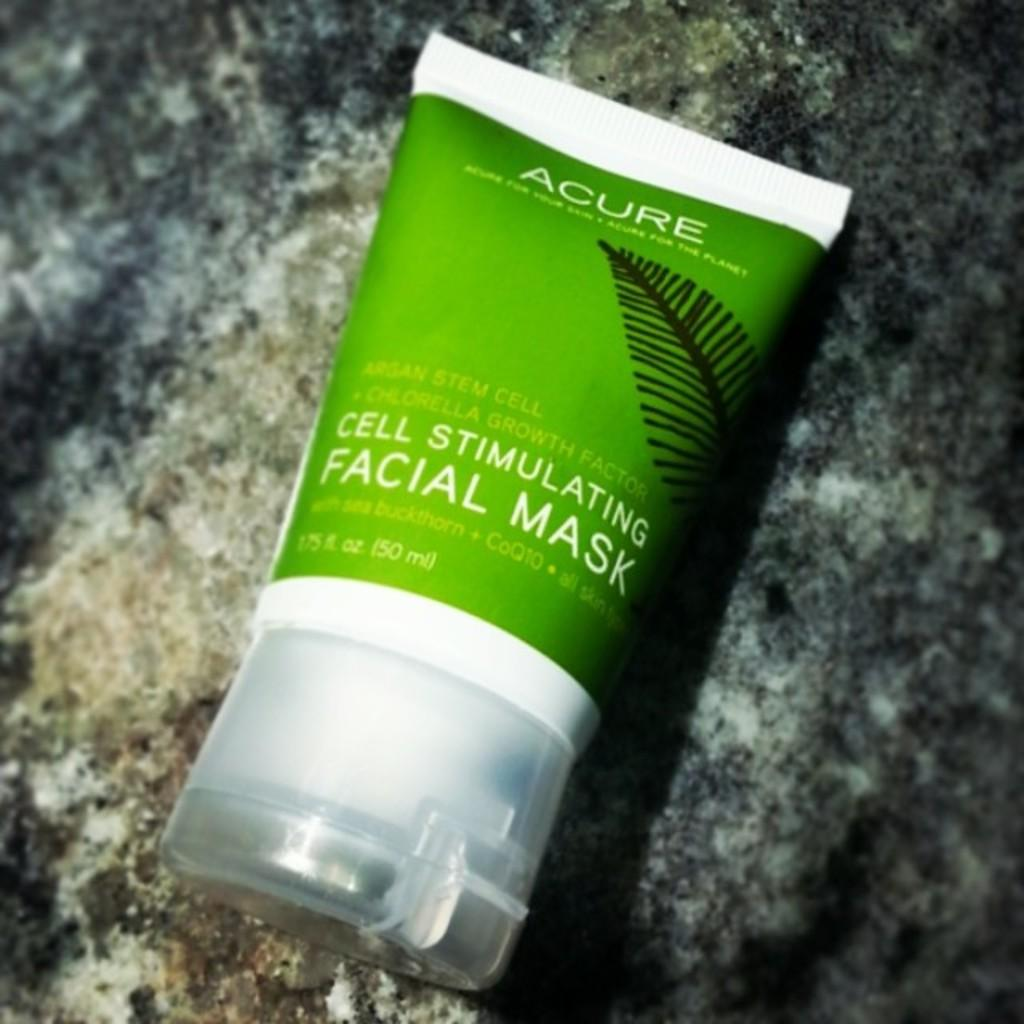<image>
Share a concise interpretation of the image provided. Green and white bottle of Acure cell stimulating facial mask 